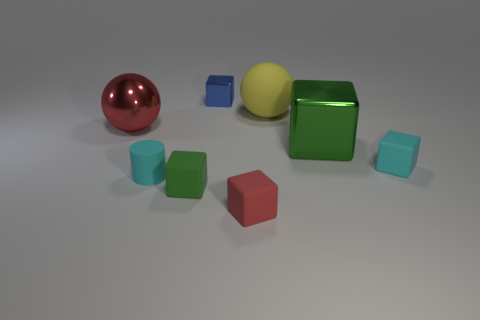Is there any other thing that is the same size as the matte cylinder?
Your response must be concise. Yes. What number of other objects are there of the same shape as the tiny blue thing?
Provide a succinct answer. 4. Is the size of the shiny thing left of the matte cylinder the same as the metallic block that is in front of the large rubber sphere?
Your answer should be very brief. Yes. Are there any other things that are made of the same material as the red sphere?
Keep it short and to the point. Yes. The cyan thing that is on the right side of the small cyan thing that is on the left side of the large ball that is right of the red ball is made of what material?
Ensure brevity in your answer.  Rubber. Does the green rubber object have the same shape as the large matte thing?
Your response must be concise. No. There is a tiny cyan thing that is the same shape as the small red matte thing; what is it made of?
Make the answer very short. Rubber. How many matte blocks have the same color as the tiny rubber cylinder?
Your response must be concise. 1. There is a green cube that is made of the same material as the big yellow ball; what is its size?
Your answer should be compact. Small. What number of red objects are either tiny shiny spheres or matte objects?
Ensure brevity in your answer.  1. 